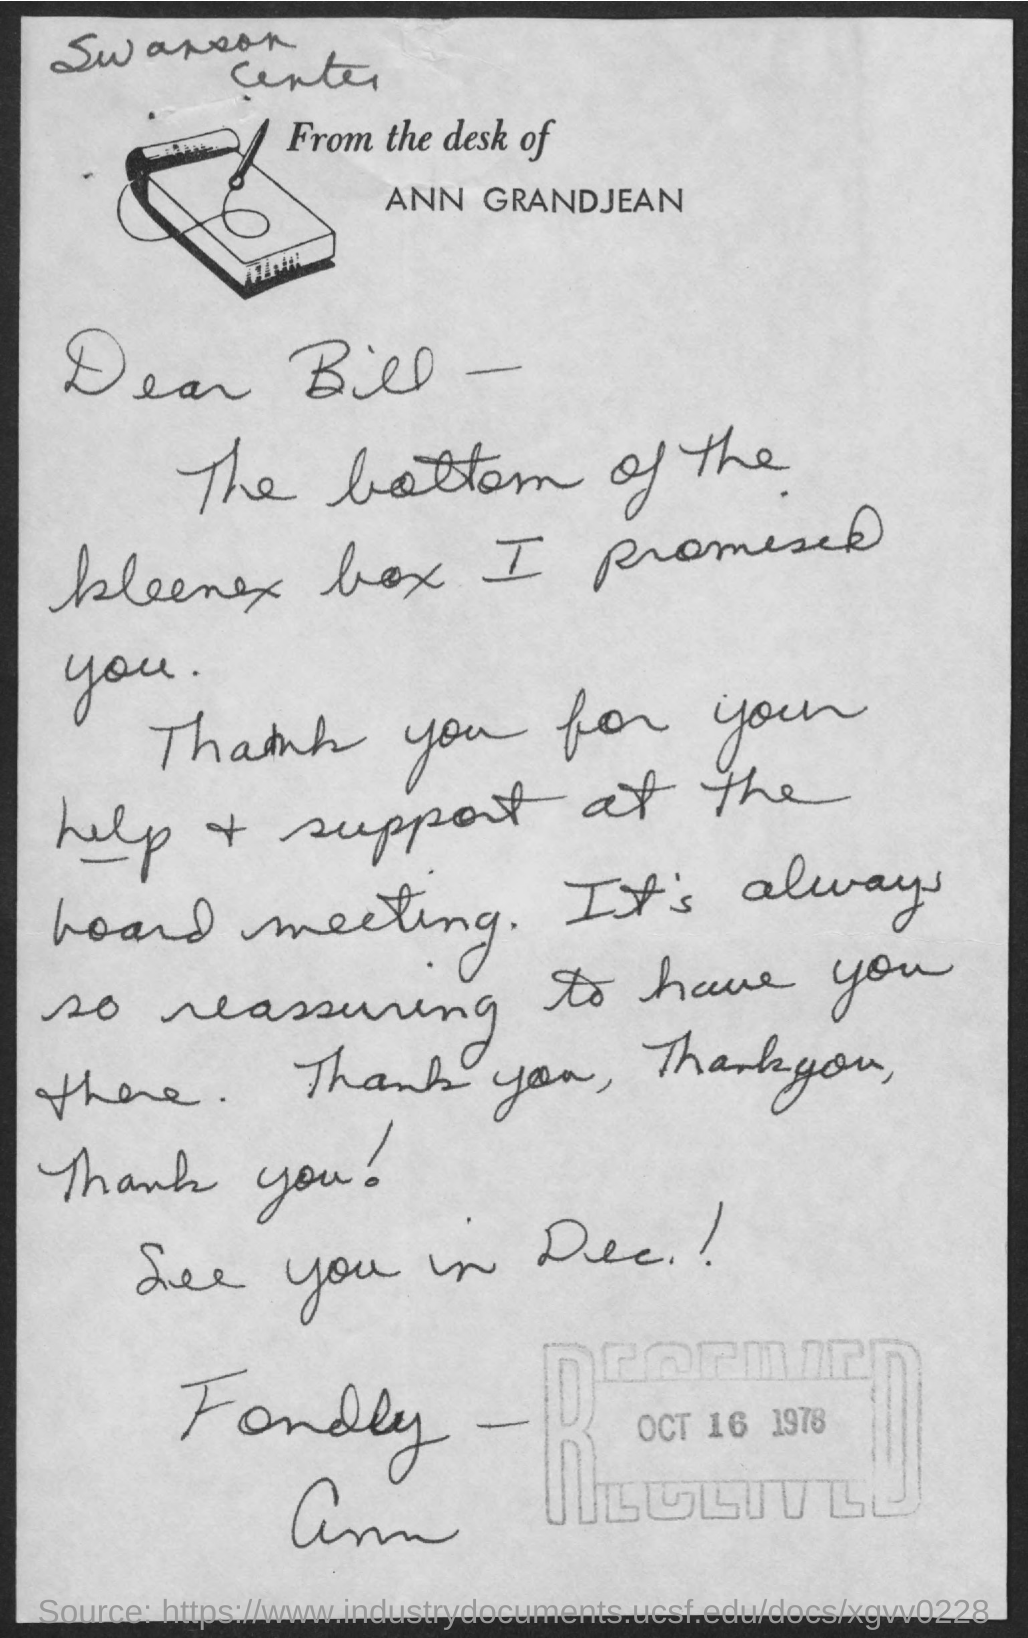To whom, the letter is addressed?
Make the answer very short. Bill. Who is the sender of this letter?
Your response must be concise. ANN. 